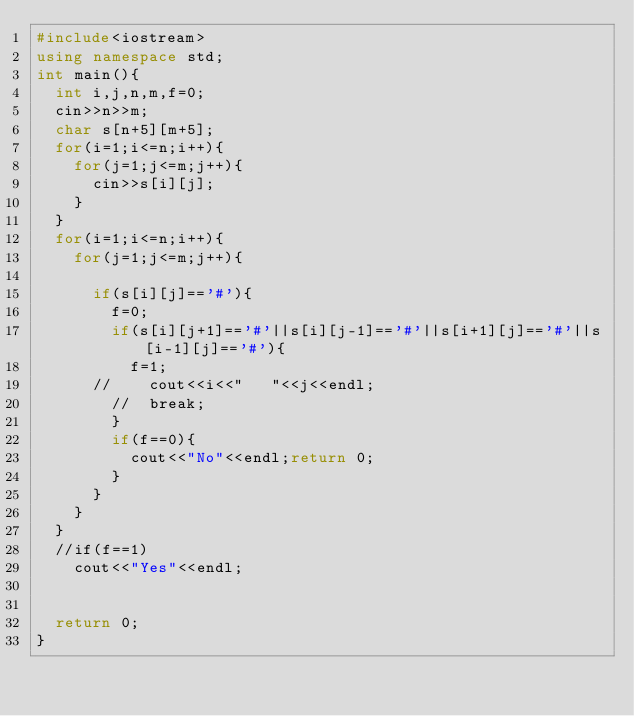Convert code to text. <code><loc_0><loc_0><loc_500><loc_500><_C++_>#include<iostream>
using namespace std;
int main(){ 
	int i,j,n,m,f=0;
	cin>>n>>m;
	char s[n+5][m+5];
	for(i=1;i<=n;i++){
		for(j=1;j<=m;j++){
			cin>>s[i][j];
		}
	}
	for(i=1;i<=n;i++){
		for(j=1;j<=m;j++){
		
			if(s[i][j]=='#'){
				f=0;
				if(s[i][j+1]=='#'||s[i][j-1]=='#'||s[i+1][j]=='#'||s[i-1][j]=='#'){
					f=1;
			//		cout<<i<<"   "<<j<<endl;
				//	break;
				}
				if(f==0){
					cout<<"No"<<endl;return 0;
				}
			}	
		}
	}
	//if(f==1)
		cout<<"Yes"<<endl;
	
		
	return 0;
}
</code> 